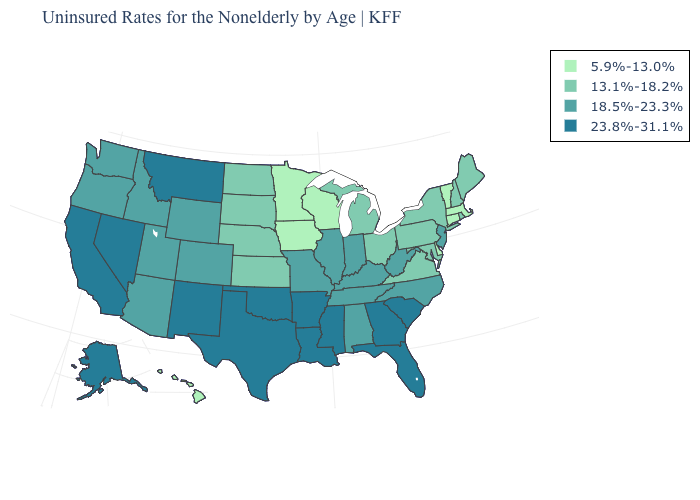Does the first symbol in the legend represent the smallest category?
Answer briefly. Yes. Does New Jersey have the same value as West Virginia?
Answer briefly. Yes. Among the states that border Kansas , which have the lowest value?
Be succinct. Nebraska. Name the states that have a value in the range 13.1%-18.2%?
Answer briefly. Kansas, Maine, Maryland, Michigan, Nebraska, New Hampshire, New York, North Dakota, Ohio, Pennsylvania, Rhode Island, South Dakota, Virginia. What is the lowest value in the MidWest?
Answer briefly. 5.9%-13.0%. What is the value of Louisiana?
Quick response, please. 23.8%-31.1%. Name the states that have a value in the range 18.5%-23.3%?
Keep it brief. Alabama, Arizona, Colorado, Idaho, Illinois, Indiana, Kentucky, Missouri, New Jersey, North Carolina, Oregon, Tennessee, Utah, Washington, West Virginia, Wyoming. Among the states that border Nevada , which have the highest value?
Write a very short answer. California. Which states have the highest value in the USA?
Be succinct. Alaska, Arkansas, California, Florida, Georgia, Louisiana, Mississippi, Montana, Nevada, New Mexico, Oklahoma, South Carolina, Texas. Which states have the highest value in the USA?
Keep it brief. Alaska, Arkansas, California, Florida, Georgia, Louisiana, Mississippi, Montana, Nevada, New Mexico, Oklahoma, South Carolina, Texas. Which states have the lowest value in the USA?
Answer briefly. Connecticut, Delaware, Hawaii, Iowa, Massachusetts, Minnesota, Vermont, Wisconsin. Name the states that have a value in the range 5.9%-13.0%?
Concise answer only. Connecticut, Delaware, Hawaii, Iowa, Massachusetts, Minnesota, Vermont, Wisconsin. What is the highest value in states that border Tennessee?
Short answer required. 23.8%-31.1%. Does South Carolina have a higher value than California?
Write a very short answer. No. Which states have the lowest value in the South?
Give a very brief answer. Delaware. 